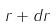<formula> <loc_0><loc_0><loc_500><loc_500>r + d r</formula> 